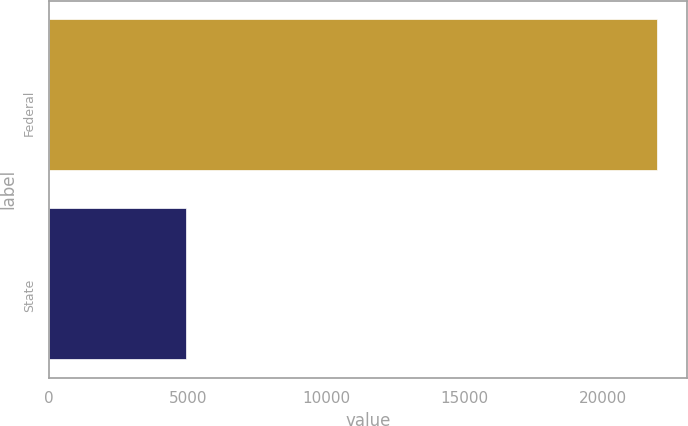Convert chart. <chart><loc_0><loc_0><loc_500><loc_500><bar_chart><fcel>Federal<fcel>State<nl><fcel>21940<fcel>4953<nl></chart> 